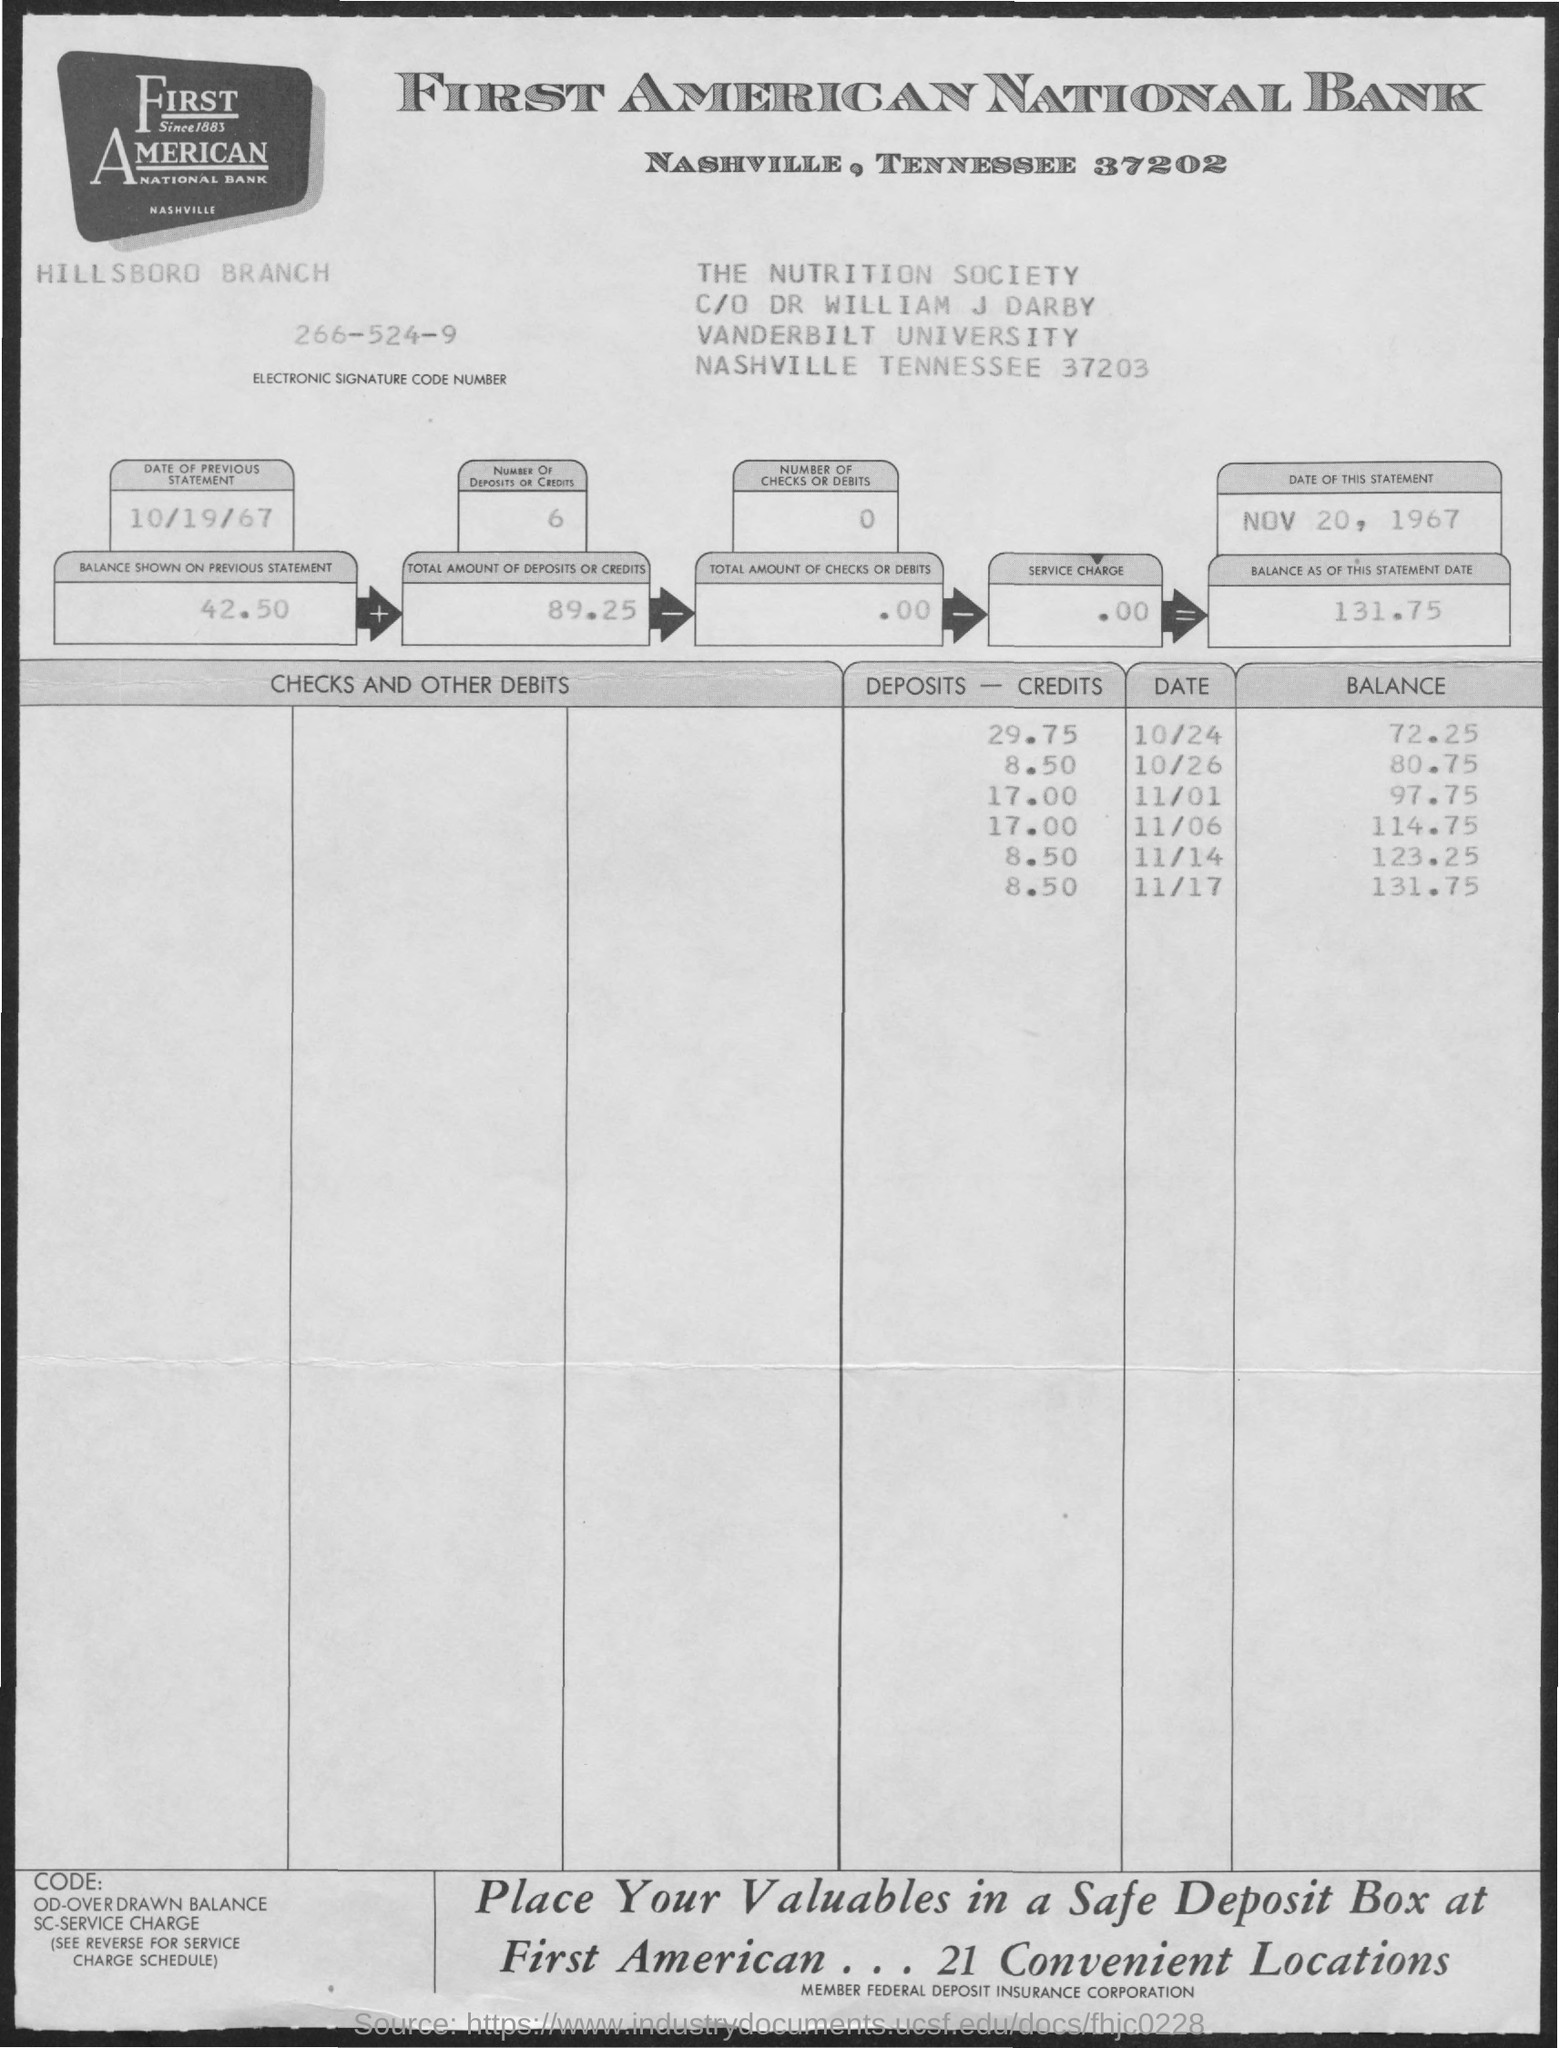What is the electronic Signature Code Number given in the statement?
Offer a terse response. 266-524-9. What is the date of previous statement?
Offer a terse response. 10/19/67. What is the date of this statement?
Provide a succinct answer. Nov 20, 1967. What is the balance shown on the previous statement?
Your answer should be compact. 42.50. What is the balance as of this statement date?
Give a very brief answer. 131.75. What is the total amount of deposits or credits given in the statement?
Offer a terse response. 89.25. 